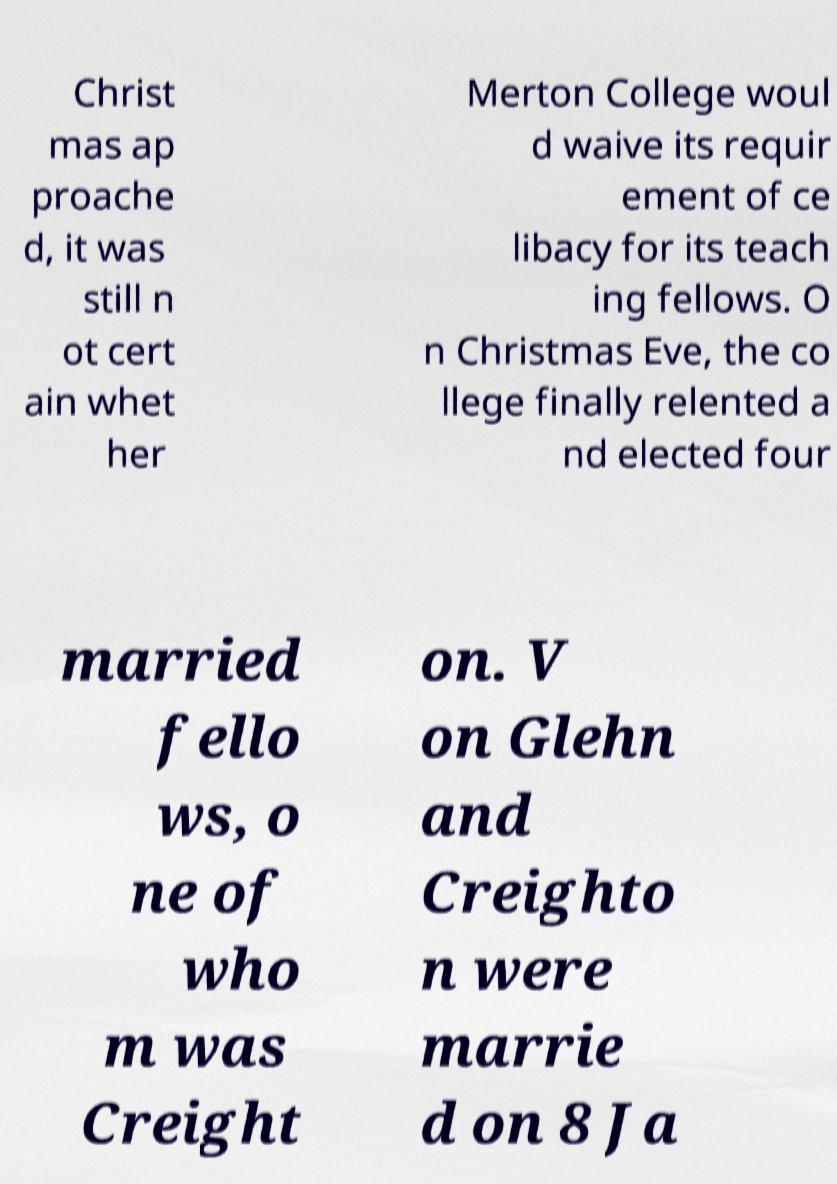For documentation purposes, I need the text within this image transcribed. Could you provide that? Christ mas ap proache d, it was still n ot cert ain whet her Merton College woul d waive its requir ement of ce libacy for its teach ing fellows. O n Christmas Eve, the co llege finally relented a nd elected four married fello ws, o ne of who m was Creight on. V on Glehn and Creighto n were marrie d on 8 Ja 